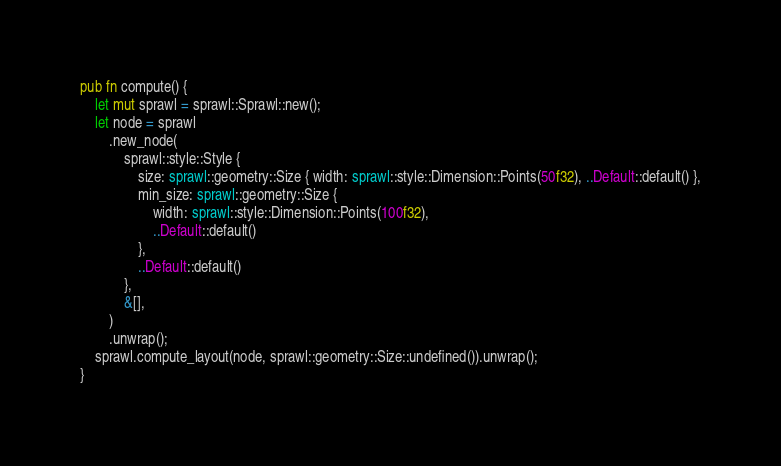Convert code to text. <code><loc_0><loc_0><loc_500><loc_500><_Rust_>pub fn compute() {
    let mut sprawl = sprawl::Sprawl::new();
    let node = sprawl
        .new_node(
            sprawl::style::Style {
                size: sprawl::geometry::Size { width: sprawl::style::Dimension::Points(50f32), ..Default::default() },
                min_size: sprawl::geometry::Size {
                    width: sprawl::style::Dimension::Points(100f32),
                    ..Default::default()
                },
                ..Default::default()
            },
            &[],
        )
        .unwrap();
    sprawl.compute_layout(node, sprawl::geometry::Size::undefined()).unwrap();
}
</code> 